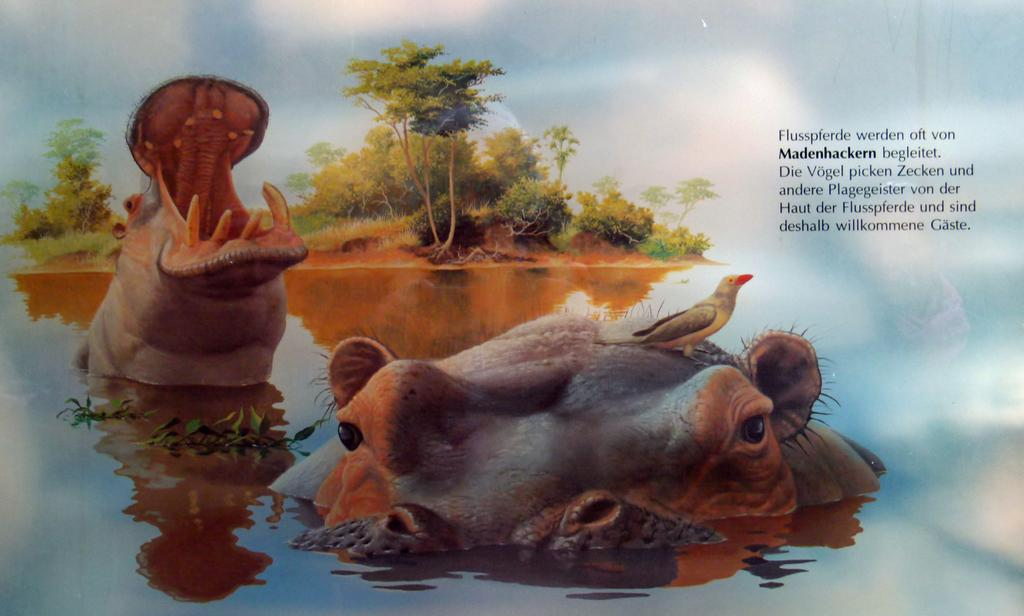What animal is depicted in the water body in the image? There is a picture of a hippopotamus in a water body in the image. What other living creature can be seen in the image? There is a bird in the image. What type of vegetation is present in the image? There is a group of trees in the image. How would you describe the sky in the image? The sky is visible and appears cloudy in the image. Is there any text present in the image? Yes, there is some text on the image. What type of leaf is being used as a floor mat in the image? There is no leaf being used as a floor mat in the image; it features a picture of a hippopotamus in a water body, a bird, a group of trees, a cloudy sky, and some text. What type of teeth can be seen in the image? There are no teeth visible in the image; it features a picture of a hippopotamus in a water body, a bird, a group of trees, a cloudy sky, and some text. 